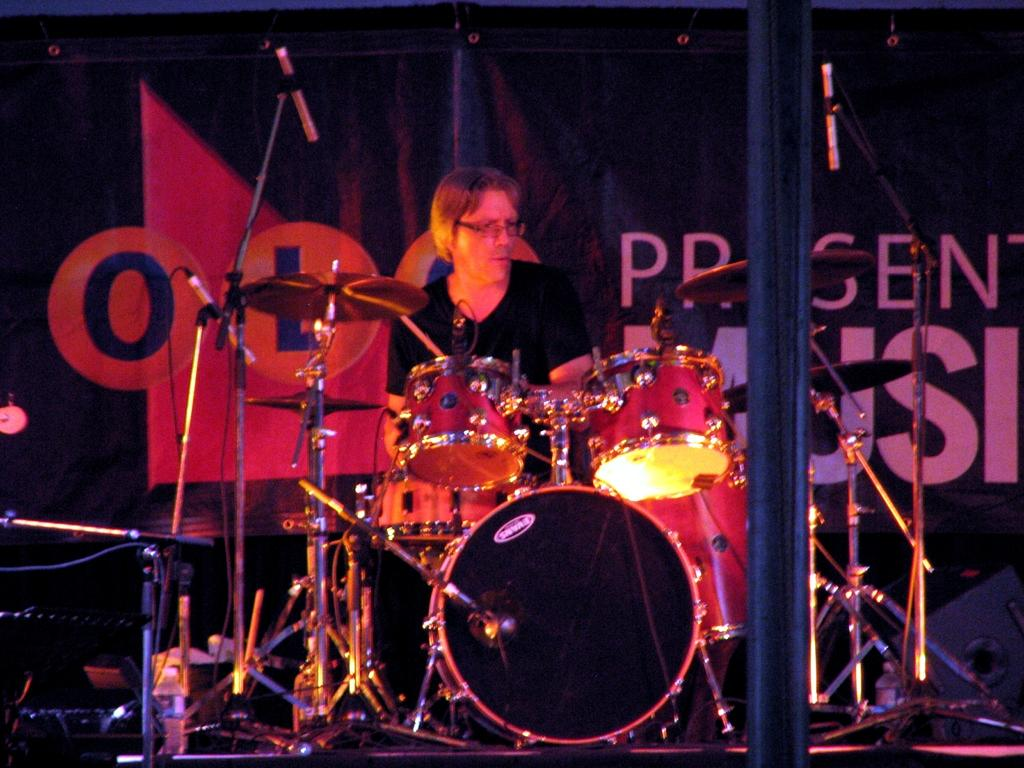Who is the main subject in the image? There is a man in the image. Where is the man located in the image? The man is sitting on a stage. What is the man doing in the image? The man is playing a musical instrument. What type of oil can be seen dripping from the instrument in the image? There is no oil present in the image, nor is there any indication of an instrument dripping oil. 